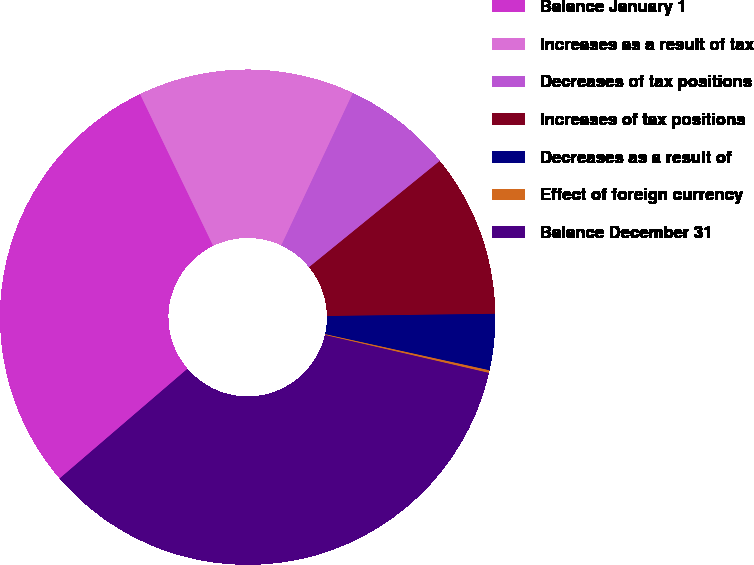Convert chart to OTSL. <chart><loc_0><loc_0><loc_500><loc_500><pie_chart><fcel>Balance January 1<fcel>Increases as a result of tax<fcel>Decreases of tax positions<fcel>Increases of tax positions<fcel>Decreases as a result of<fcel>Effect of foreign currency<fcel>Balance December 31<nl><fcel>29.14%<fcel>14.14%<fcel>7.15%<fcel>10.65%<fcel>3.66%<fcel>0.17%<fcel>35.1%<nl></chart> 